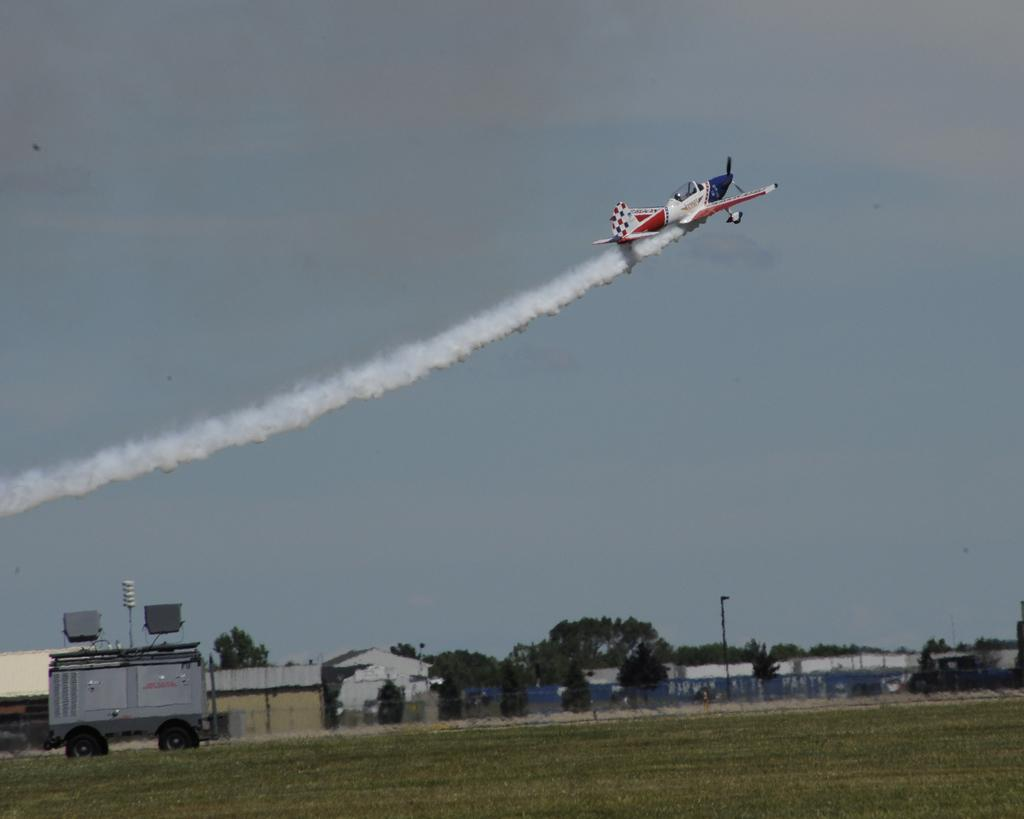What is the main subject of the image? The main subject of the image is an airplane. What is the airplane doing in the image? The airplane is flying in the air and releasing smoke. What can be seen on the ground in the image? Buildings, trees, and vehicles are visible on the ground in the image. What part of the natural environment is visible in the image? The sky is visible in the image. What type of bread can be seen on the stage in the image? There is no stage or bread present in the image; it features an airplane flying in the air and releasing smoke, with buildings, trees, and vehicles visible on the ground. 